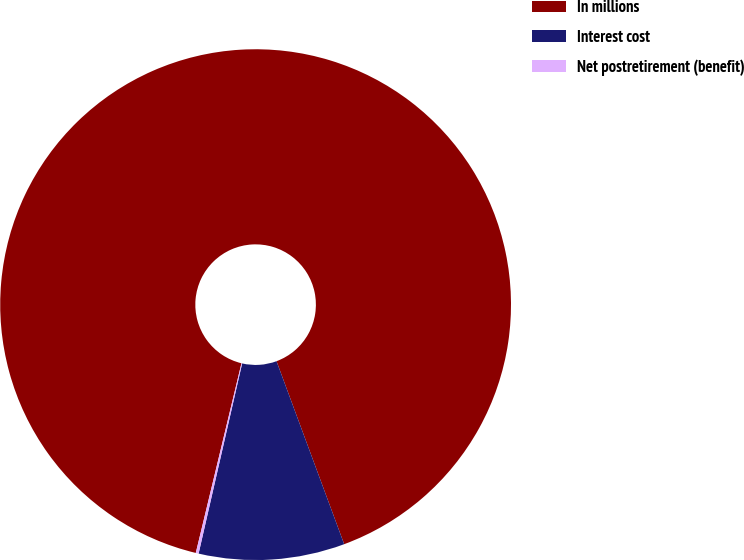Convert chart. <chart><loc_0><loc_0><loc_500><loc_500><pie_chart><fcel>In millions<fcel>Interest cost<fcel>Net postretirement (benefit)<nl><fcel>90.6%<fcel>9.22%<fcel>0.18%<nl></chart> 